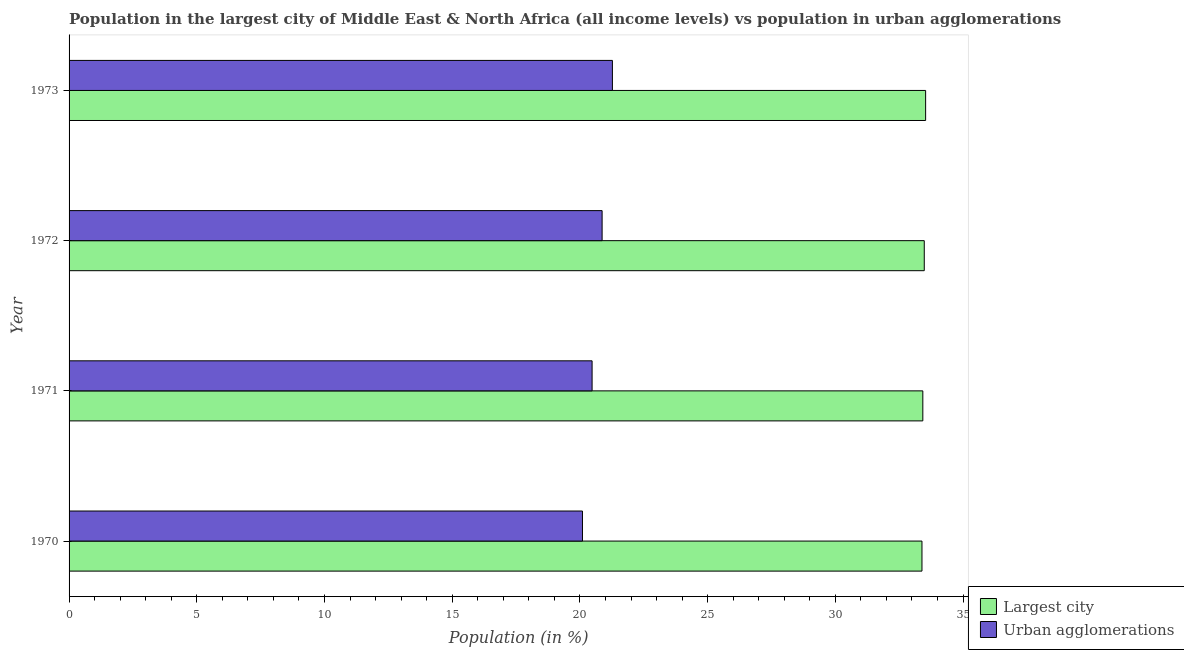How many different coloured bars are there?
Your response must be concise. 2. How many bars are there on the 3rd tick from the top?
Offer a terse response. 2. How many bars are there on the 3rd tick from the bottom?
Provide a succinct answer. 2. What is the label of the 2nd group of bars from the top?
Offer a terse response. 1972. What is the population in the largest city in 1972?
Your answer should be compact. 33.48. Across all years, what is the maximum population in urban agglomerations?
Your response must be concise. 21.27. Across all years, what is the minimum population in urban agglomerations?
Offer a very short reply. 20.1. In which year was the population in the largest city minimum?
Offer a very short reply. 1970. What is the total population in the largest city in the graph?
Your response must be concise. 133.84. What is the difference between the population in urban agglomerations in 1971 and that in 1972?
Your answer should be very brief. -0.39. What is the difference between the population in the largest city in 1972 and the population in urban agglomerations in 1973?
Provide a short and direct response. 12.21. What is the average population in the largest city per year?
Offer a very short reply. 33.46. In the year 1970, what is the difference between the population in the largest city and population in urban agglomerations?
Give a very brief answer. 13.29. In how many years, is the population in urban agglomerations greater than 21 %?
Provide a short and direct response. 1. What is the ratio of the population in the largest city in 1971 to that in 1973?
Provide a succinct answer. 1. Is the population in urban agglomerations in 1971 less than that in 1972?
Your answer should be compact. Yes. Is the difference between the population in the largest city in 1971 and 1972 greater than the difference between the population in urban agglomerations in 1971 and 1972?
Offer a very short reply. Yes. What is the difference between the highest and the second highest population in the largest city?
Your answer should be very brief. 0.05. What is the difference between the highest and the lowest population in urban agglomerations?
Provide a succinct answer. 1.17. In how many years, is the population in urban agglomerations greater than the average population in urban agglomerations taken over all years?
Offer a terse response. 2. Is the sum of the population in urban agglomerations in 1970 and 1972 greater than the maximum population in the largest city across all years?
Your answer should be compact. Yes. What does the 2nd bar from the top in 1972 represents?
Make the answer very short. Largest city. What does the 1st bar from the bottom in 1970 represents?
Make the answer very short. Largest city. How many years are there in the graph?
Keep it short and to the point. 4. Where does the legend appear in the graph?
Keep it short and to the point. Bottom right. How are the legend labels stacked?
Give a very brief answer. Vertical. What is the title of the graph?
Your answer should be very brief. Population in the largest city of Middle East & North Africa (all income levels) vs population in urban agglomerations. What is the label or title of the X-axis?
Provide a short and direct response. Population (in %). What is the Population (in %) of Largest city in 1970?
Make the answer very short. 33.39. What is the Population (in %) in Urban agglomerations in 1970?
Provide a succinct answer. 20.1. What is the Population (in %) of Largest city in 1971?
Your answer should be compact. 33.43. What is the Population (in %) in Urban agglomerations in 1971?
Your answer should be very brief. 20.48. What is the Population (in %) in Largest city in 1972?
Keep it short and to the point. 33.48. What is the Population (in %) in Urban agglomerations in 1972?
Your response must be concise. 20.87. What is the Population (in %) in Largest city in 1973?
Your answer should be compact. 33.53. What is the Population (in %) in Urban agglomerations in 1973?
Your answer should be very brief. 21.27. Across all years, what is the maximum Population (in %) in Largest city?
Provide a succinct answer. 33.53. Across all years, what is the maximum Population (in %) in Urban agglomerations?
Give a very brief answer. 21.27. Across all years, what is the minimum Population (in %) in Largest city?
Ensure brevity in your answer.  33.39. Across all years, what is the minimum Population (in %) in Urban agglomerations?
Ensure brevity in your answer.  20.1. What is the total Population (in %) in Largest city in the graph?
Offer a terse response. 133.84. What is the total Population (in %) in Urban agglomerations in the graph?
Ensure brevity in your answer.  82.72. What is the difference between the Population (in %) in Largest city in 1970 and that in 1971?
Ensure brevity in your answer.  -0.03. What is the difference between the Population (in %) of Urban agglomerations in 1970 and that in 1971?
Provide a succinct answer. -0.38. What is the difference between the Population (in %) of Largest city in 1970 and that in 1972?
Offer a terse response. -0.09. What is the difference between the Population (in %) in Urban agglomerations in 1970 and that in 1972?
Offer a very short reply. -0.77. What is the difference between the Population (in %) in Largest city in 1970 and that in 1973?
Provide a short and direct response. -0.14. What is the difference between the Population (in %) of Urban agglomerations in 1970 and that in 1973?
Your response must be concise. -1.17. What is the difference between the Population (in %) in Largest city in 1971 and that in 1972?
Your answer should be very brief. -0.06. What is the difference between the Population (in %) in Urban agglomerations in 1971 and that in 1972?
Provide a short and direct response. -0.39. What is the difference between the Population (in %) in Largest city in 1971 and that in 1973?
Make the answer very short. -0.11. What is the difference between the Population (in %) of Urban agglomerations in 1971 and that in 1973?
Offer a very short reply. -0.8. What is the difference between the Population (in %) in Largest city in 1972 and that in 1973?
Provide a succinct answer. -0.05. What is the difference between the Population (in %) in Urban agglomerations in 1972 and that in 1973?
Give a very brief answer. -0.4. What is the difference between the Population (in %) in Largest city in 1970 and the Population (in %) in Urban agglomerations in 1971?
Make the answer very short. 12.92. What is the difference between the Population (in %) in Largest city in 1970 and the Population (in %) in Urban agglomerations in 1972?
Offer a terse response. 12.52. What is the difference between the Population (in %) in Largest city in 1970 and the Population (in %) in Urban agglomerations in 1973?
Your answer should be compact. 12.12. What is the difference between the Population (in %) in Largest city in 1971 and the Population (in %) in Urban agglomerations in 1972?
Ensure brevity in your answer.  12.56. What is the difference between the Population (in %) of Largest city in 1971 and the Population (in %) of Urban agglomerations in 1973?
Your answer should be very brief. 12.15. What is the difference between the Population (in %) in Largest city in 1972 and the Population (in %) in Urban agglomerations in 1973?
Your response must be concise. 12.21. What is the average Population (in %) of Largest city per year?
Your response must be concise. 33.46. What is the average Population (in %) of Urban agglomerations per year?
Provide a succinct answer. 20.68. In the year 1970, what is the difference between the Population (in %) of Largest city and Population (in %) of Urban agglomerations?
Offer a terse response. 13.29. In the year 1971, what is the difference between the Population (in %) in Largest city and Population (in %) in Urban agglomerations?
Your answer should be compact. 12.95. In the year 1972, what is the difference between the Population (in %) in Largest city and Population (in %) in Urban agglomerations?
Ensure brevity in your answer.  12.61. In the year 1973, what is the difference between the Population (in %) of Largest city and Population (in %) of Urban agglomerations?
Your answer should be compact. 12.26. What is the ratio of the Population (in %) of Largest city in 1970 to that in 1971?
Make the answer very short. 1. What is the ratio of the Population (in %) in Urban agglomerations in 1970 to that in 1971?
Offer a very short reply. 0.98. What is the ratio of the Population (in %) of Urban agglomerations in 1970 to that in 1972?
Give a very brief answer. 0.96. What is the ratio of the Population (in %) in Largest city in 1970 to that in 1973?
Make the answer very short. 1. What is the ratio of the Population (in %) of Urban agglomerations in 1970 to that in 1973?
Provide a short and direct response. 0.94. What is the ratio of the Population (in %) in Largest city in 1971 to that in 1972?
Give a very brief answer. 1. What is the ratio of the Population (in %) of Urban agglomerations in 1971 to that in 1972?
Ensure brevity in your answer.  0.98. What is the ratio of the Population (in %) of Urban agglomerations in 1971 to that in 1973?
Offer a terse response. 0.96. What is the ratio of the Population (in %) of Largest city in 1972 to that in 1973?
Your response must be concise. 1. What is the ratio of the Population (in %) of Urban agglomerations in 1972 to that in 1973?
Ensure brevity in your answer.  0.98. What is the difference between the highest and the second highest Population (in %) in Largest city?
Your response must be concise. 0.05. What is the difference between the highest and the second highest Population (in %) in Urban agglomerations?
Make the answer very short. 0.4. What is the difference between the highest and the lowest Population (in %) of Largest city?
Your response must be concise. 0.14. What is the difference between the highest and the lowest Population (in %) in Urban agglomerations?
Your answer should be very brief. 1.17. 